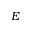<formula> <loc_0><loc_0><loc_500><loc_500>E</formula> 